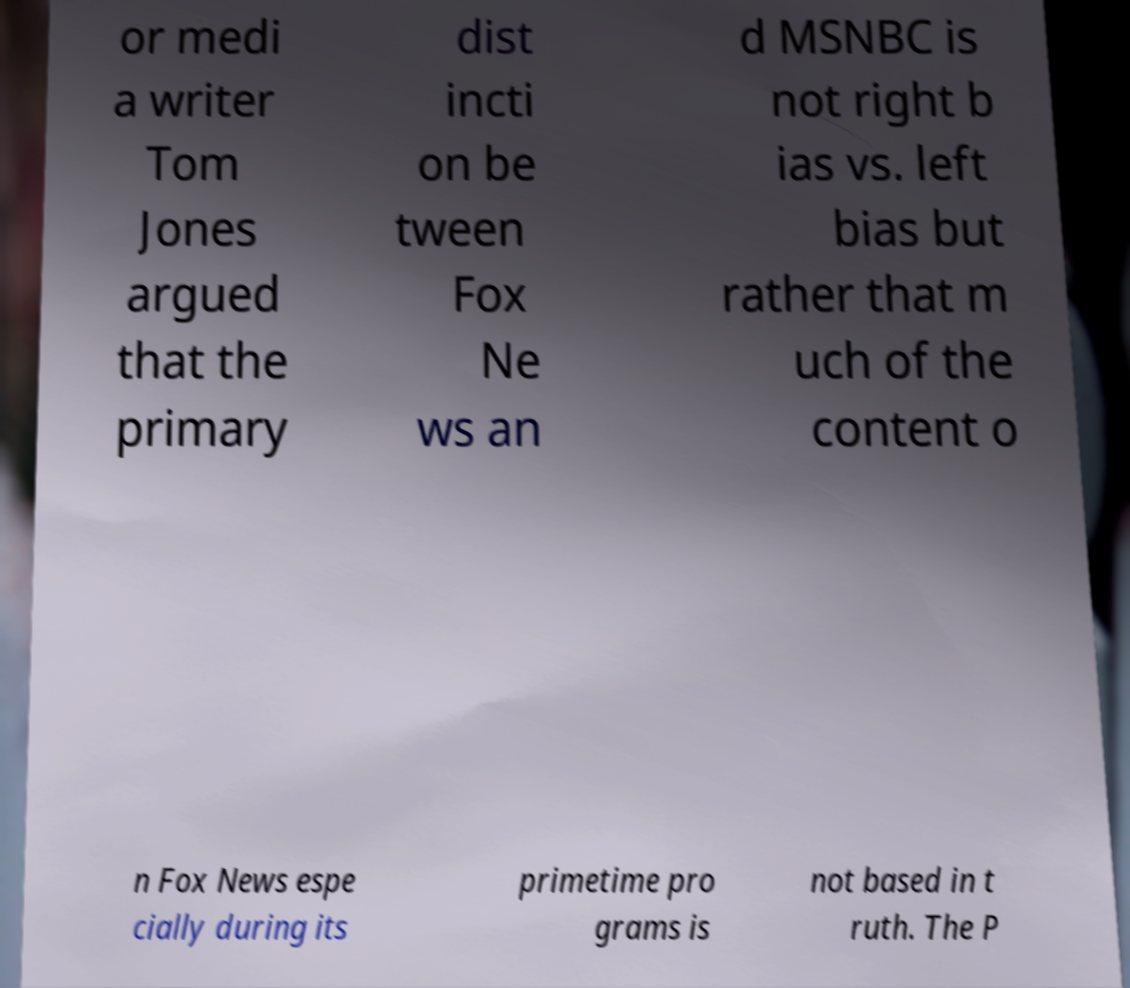Could you assist in decoding the text presented in this image and type it out clearly? or medi a writer Tom Jones argued that the primary dist incti on be tween Fox Ne ws an d MSNBC is not right b ias vs. left bias but rather that m uch of the content o n Fox News espe cially during its primetime pro grams is not based in t ruth. The P 